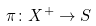Convert formula to latex. <formula><loc_0><loc_0><loc_500><loc_500>\pi \colon X ^ { + } \rightarrow S</formula> 